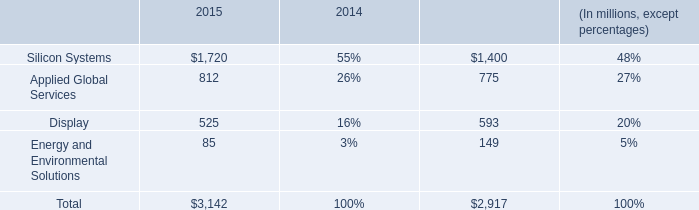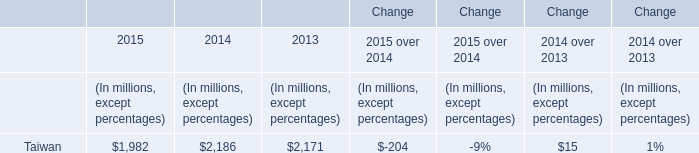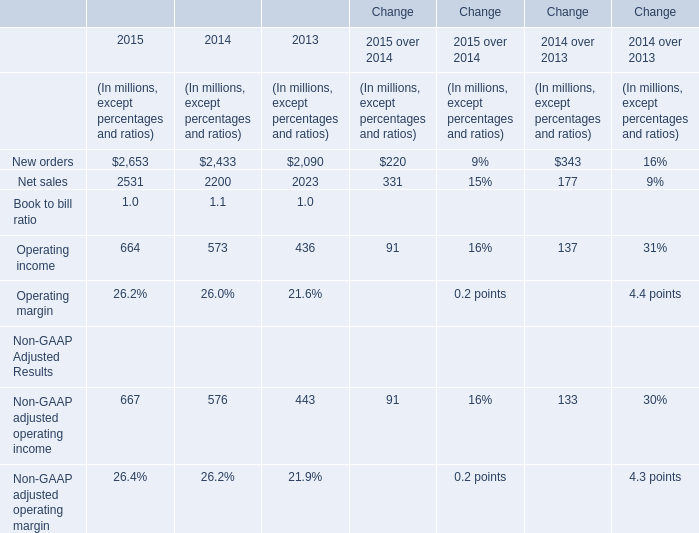how much percentage has backlog increased from 2014 to 2015 
Computations: ((3142 - 2917) / 2917)
Answer: 0.07713. 